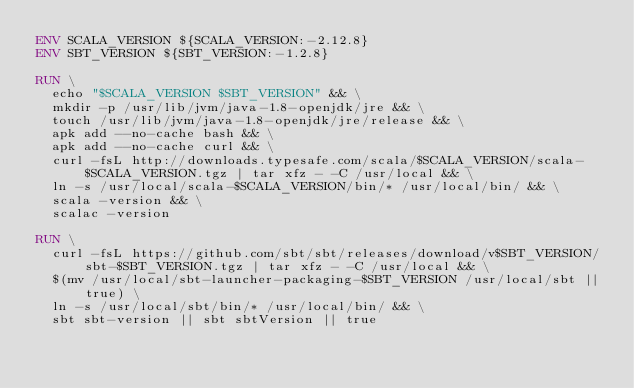Convert code to text. <code><loc_0><loc_0><loc_500><loc_500><_Dockerfile_>ENV SCALA_VERSION ${SCALA_VERSION:-2.12.8}
ENV SBT_VERSION ${SBT_VERSION:-1.2.8}

RUN \
  echo "$SCALA_VERSION $SBT_VERSION" && \
  mkdir -p /usr/lib/jvm/java-1.8-openjdk/jre && \
  touch /usr/lib/jvm/java-1.8-openjdk/jre/release && \
  apk add --no-cache bash && \
  apk add --no-cache curl && \
  curl -fsL http://downloads.typesafe.com/scala/$SCALA_VERSION/scala-$SCALA_VERSION.tgz | tar xfz - -C /usr/local && \
  ln -s /usr/local/scala-$SCALA_VERSION/bin/* /usr/local/bin/ && \
  scala -version && \
  scalac -version

RUN \
  curl -fsL https://github.com/sbt/sbt/releases/download/v$SBT_VERSION/sbt-$SBT_VERSION.tgz | tar xfz - -C /usr/local && \
  $(mv /usr/local/sbt-launcher-packaging-$SBT_VERSION /usr/local/sbt || true) \
  ln -s /usr/local/sbt/bin/* /usr/local/bin/ && \
  sbt sbt-version || sbt sbtVersion || true
</code> 